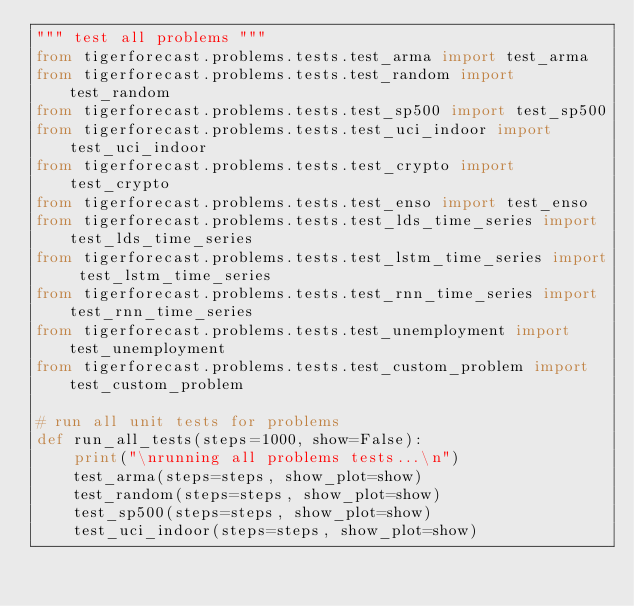<code> <loc_0><loc_0><loc_500><loc_500><_Python_>""" test all problems """
from tigerforecast.problems.tests.test_arma import test_arma
from tigerforecast.problems.tests.test_random import test_random
from tigerforecast.problems.tests.test_sp500 import test_sp500
from tigerforecast.problems.tests.test_uci_indoor import test_uci_indoor
from tigerforecast.problems.tests.test_crypto import test_crypto
from tigerforecast.problems.tests.test_enso import test_enso
from tigerforecast.problems.tests.test_lds_time_series import test_lds_time_series
from tigerforecast.problems.tests.test_lstm_time_series import test_lstm_time_series
from tigerforecast.problems.tests.test_rnn_time_series import test_rnn_time_series
from tigerforecast.problems.tests.test_unemployment import test_unemployment
from tigerforecast.problems.tests.test_custom_problem import test_custom_problem

# run all unit tests for problems
def run_all_tests(steps=1000, show=False):
    print("\nrunning all problems tests...\n")
    test_arma(steps=steps, show_plot=show)
    test_random(steps=steps, show_plot=show)
    test_sp500(steps=steps, show_plot=show)
    test_uci_indoor(steps=steps, show_plot=show)</code> 